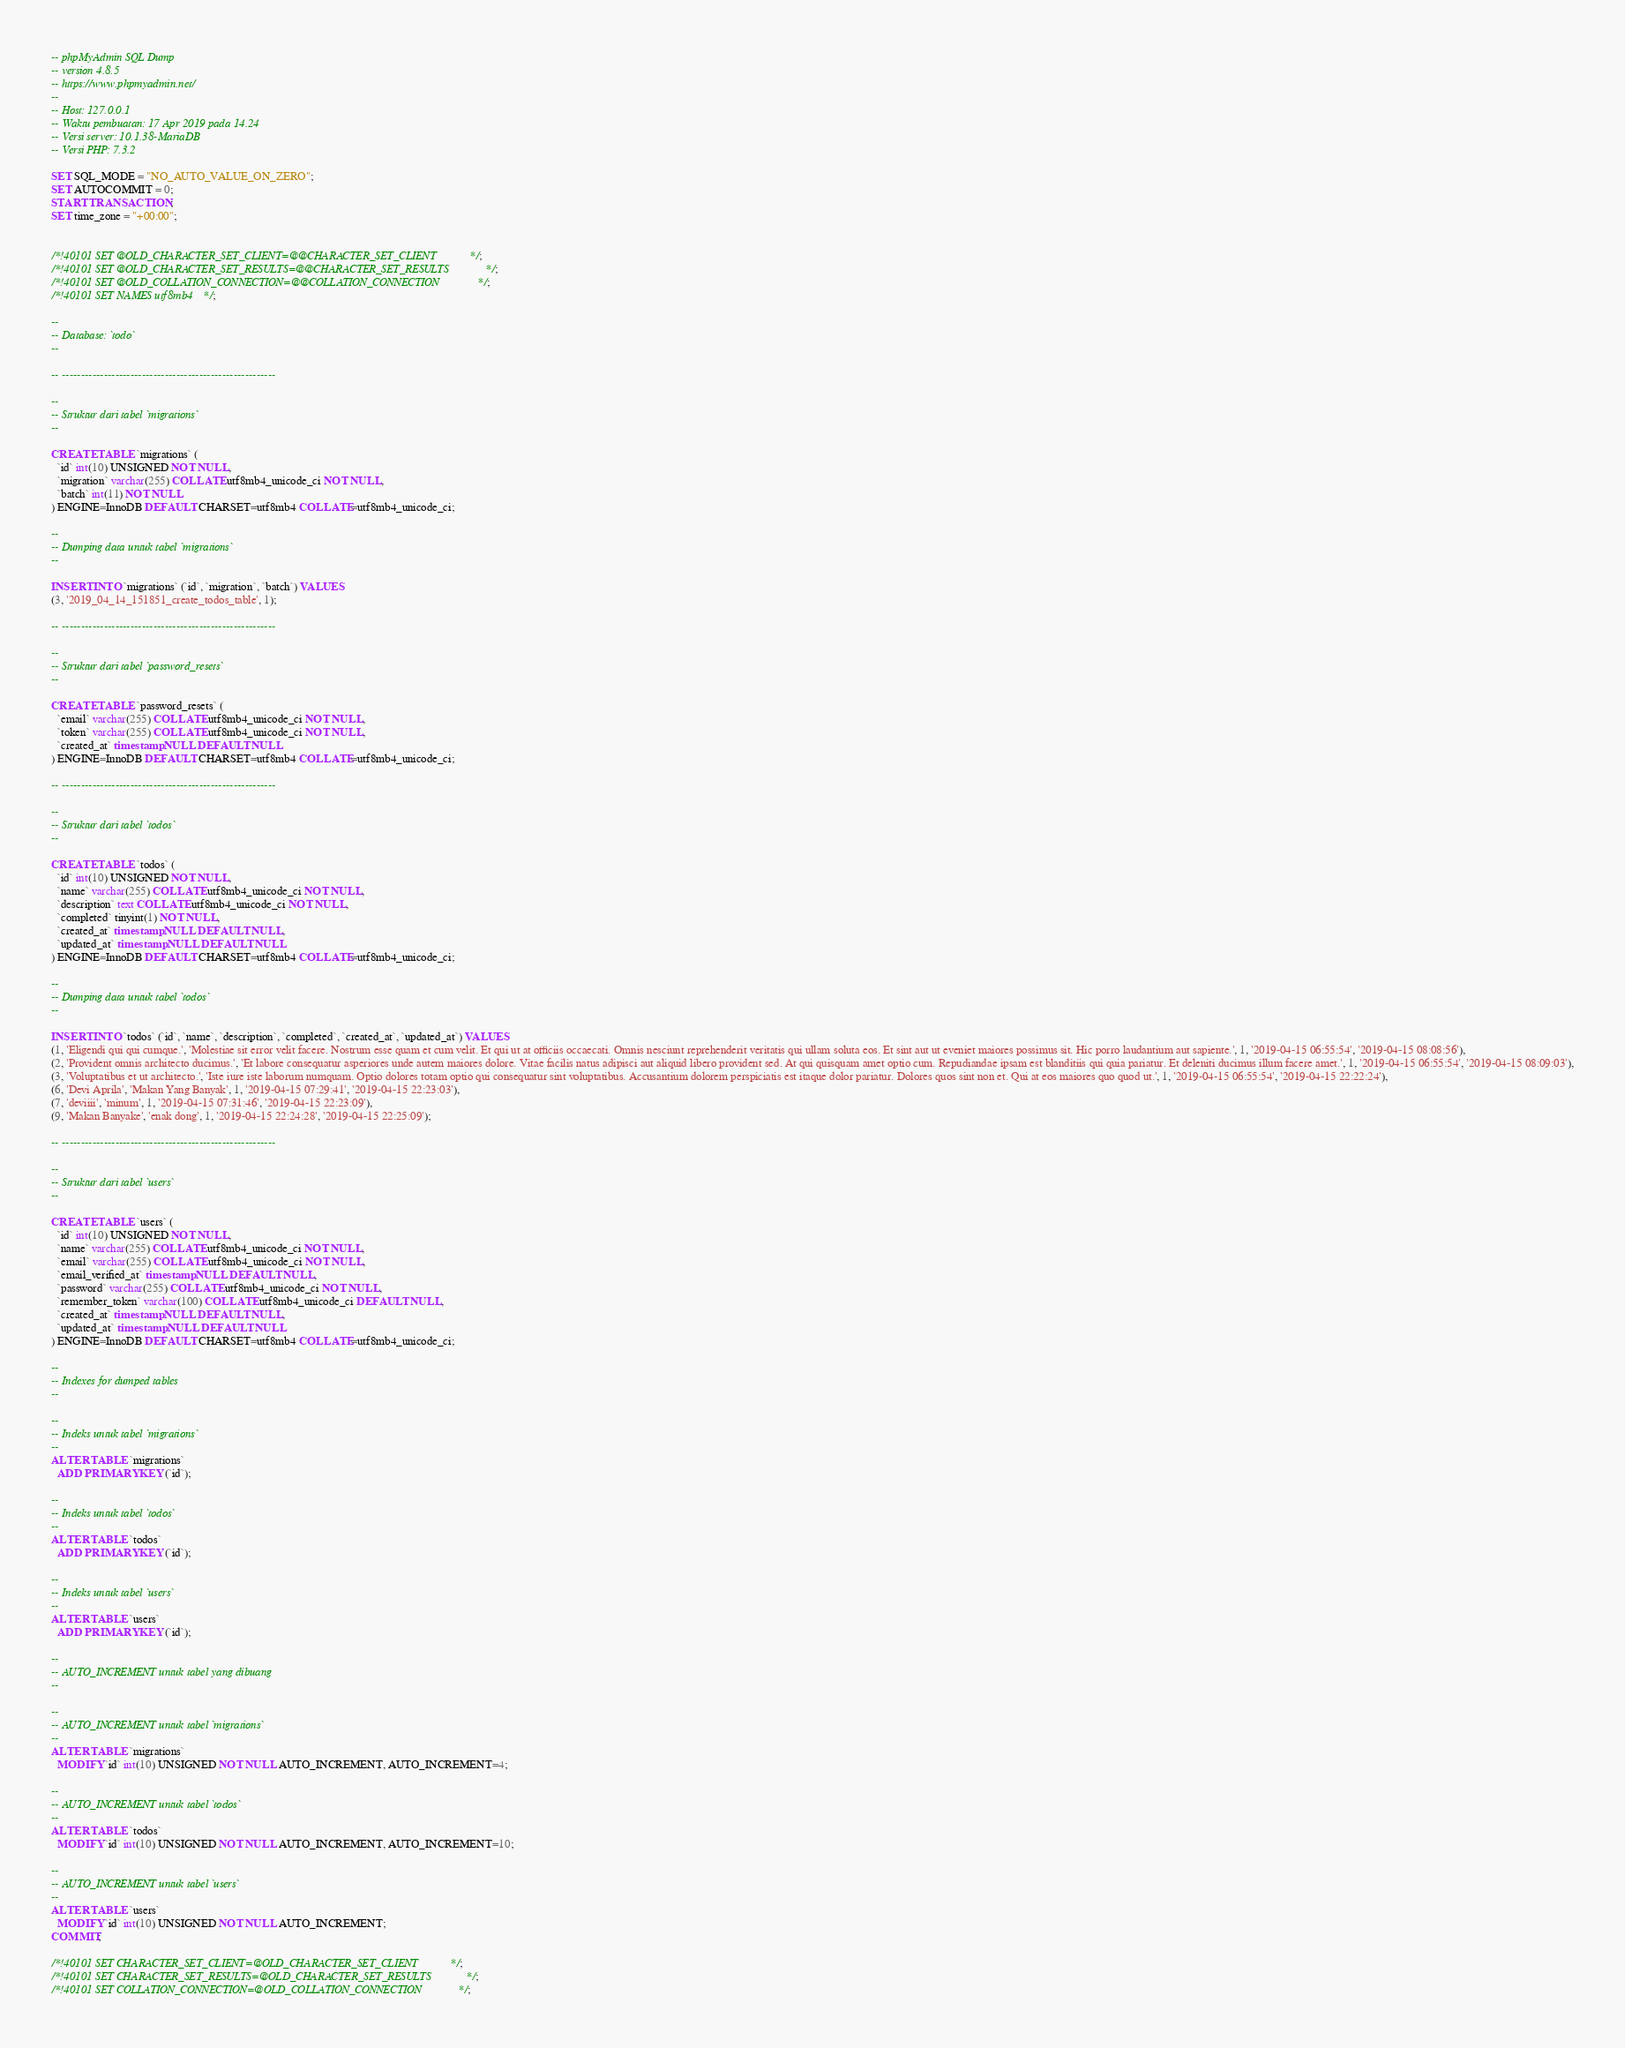<code> <loc_0><loc_0><loc_500><loc_500><_SQL_>-- phpMyAdmin SQL Dump
-- version 4.8.5
-- https://www.phpmyadmin.net/
--
-- Host: 127.0.0.1
-- Waktu pembuatan: 17 Apr 2019 pada 14.24
-- Versi server: 10.1.38-MariaDB
-- Versi PHP: 7.3.2

SET SQL_MODE = "NO_AUTO_VALUE_ON_ZERO";
SET AUTOCOMMIT = 0;
START TRANSACTION;
SET time_zone = "+00:00";


/*!40101 SET @OLD_CHARACTER_SET_CLIENT=@@CHARACTER_SET_CLIENT */;
/*!40101 SET @OLD_CHARACTER_SET_RESULTS=@@CHARACTER_SET_RESULTS */;
/*!40101 SET @OLD_COLLATION_CONNECTION=@@COLLATION_CONNECTION */;
/*!40101 SET NAMES utf8mb4 */;

--
-- Database: `todo`
--

-- --------------------------------------------------------

--
-- Struktur dari tabel `migrations`
--

CREATE TABLE `migrations` (
  `id` int(10) UNSIGNED NOT NULL,
  `migration` varchar(255) COLLATE utf8mb4_unicode_ci NOT NULL,
  `batch` int(11) NOT NULL
) ENGINE=InnoDB DEFAULT CHARSET=utf8mb4 COLLATE=utf8mb4_unicode_ci;

--
-- Dumping data untuk tabel `migrations`
--

INSERT INTO `migrations` (`id`, `migration`, `batch`) VALUES
(3, '2019_04_14_151851_create_todos_table', 1);

-- --------------------------------------------------------

--
-- Struktur dari tabel `password_resets`
--

CREATE TABLE `password_resets` (
  `email` varchar(255) COLLATE utf8mb4_unicode_ci NOT NULL,
  `token` varchar(255) COLLATE utf8mb4_unicode_ci NOT NULL,
  `created_at` timestamp NULL DEFAULT NULL
) ENGINE=InnoDB DEFAULT CHARSET=utf8mb4 COLLATE=utf8mb4_unicode_ci;

-- --------------------------------------------------------

--
-- Struktur dari tabel `todos`
--

CREATE TABLE `todos` (
  `id` int(10) UNSIGNED NOT NULL,
  `name` varchar(255) COLLATE utf8mb4_unicode_ci NOT NULL,
  `description` text COLLATE utf8mb4_unicode_ci NOT NULL,
  `completed` tinyint(1) NOT NULL,
  `created_at` timestamp NULL DEFAULT NULL,
  `updated_at` timestamp NULL DEFAULT NULL
) ENGINE=InnoDB DEFAULT CHARSET=utf8mb4 COLLATE=utf8mb4_unicode_ci;

--
-- Dumping data untuk tabel `todos`
--

INSERT INTO `todos` (`id`, `name`, `description`, `completed`, `created_at`, `updated_at`) VALUES
(1, 'Eligendi qui qui cumque.', 'Molestiae sit error velit facere. Nostrum esse quam et cum velit. Et qui ut at officiis occaecati. Omnis nesciunt reprehenderit veritatis qui ullam soluta eos. Et sint aut ut eveniet maiores possimus sit. Hic porro laudantium aut sapiente.', 1, '2019-04-15 06:55:54', '2019-04-15 08:08:56'),
(2, 'Provident omnis architecto ducimus.', 'Et labore consequatur asperiores unde autem maiores dolore. Vitae facilis natus adipisci aut aliquid libero provident sed. At qui quisquam amet optio cum. Repudiandae ipsam est blanditiis qui quia pariatur. Et deleniti ducimus illum facere amet.', 1, '2019-04-15 06:55:54', '2019-04-15 08:09:03'),
(3, 'Voluptatibus et ut architecto.', 'Iste iure iste laborum numquam. Optio dolores totam optio qui consequatur sint voluptatibus. Accusantium dolorem perspiciatis est itaque dolor pariatur. Dolores quos sint non et. Qui at eos maiores quo quod ut.', 1, '2019-04-15 06:55:54', '2019-04-15 22:22:24'),
(6, 'Devi Aprila', 'Makan Yang Banyak', 1, '2019-04-15 07:29:41', '2019-04-15 22:23:03'),
(7, 'deviiii', 'minum', 1, '2019-04-15 07:31:46', '2019-04-15 22:23:09'),
(9, 'Makan Banyake', 'enak dong', 1, '2019-04-15 22:24:28', '2019-04-15 22:25:09');

-- --------------------------------------------------------

--
-- Struktur dari tabel `users`
--

CREATE TABLE `users` (
  `id` int(10) UNSIGNED NOT NULL,
  `name` varchar(255) COLLATE utf8mb4_unicode_ci NOT NULL,
  `email` varchar(255) COLLATE utf8mb4_unicode_ci NOT NULL,
  `email_verified_at` timestamp NULL DEFAULT NULL,
  `password` varchar(255) COLLATE utf8mb4_unicode_ci NOT NULL,
  `remember_token` varchar(100) COLLATE utf8mb4_unicode_ci DEFAULT NULL,
  `created_at` timestamp NULL DEFAULT NULL,
  `updated_at` timestamp NULL DEFAULT NULL
) ENGINE=InnoDB DEFAULT CHARSET=utf8mb4 COLLATE=utf8mb4_unicode_ci;

--
-- Indexes for dumped tables
--

--
-- Indeks untuk tabel `migrations`
--
ALTER TABLE `migrations`
  ADD PRIMARY KEY (`id`);

--
-- Indeks untuk tabel `todos`
--
ALTER TABLE `todos`
  ADD PRIMARY KEY (`id`);

--
-- Indeks untuk tabel `users`
--
ALTER TABLE `users`
  ADD PRIMARY KEY (`id`);

--
-- AUTO_INCREMENT untuk tabel yang dibuang
--

--
-- AUTO_INCREMENT untuk tabel `migrations`
--
ALTER TABLE `migrations`
  MODIFY `id` int(10) UNSIGNED NOT NULL AUTO_INCREMENT, AUTO_INCREMENT=4;

--
-- AUTO_INCREMENT untuk tabel `todos`
--
ALTER TABLE `todos`
  MODIFY `id` int(10) UNSIGNED NOT NULL AUTO_INCREMENT, AUTO_INCREMENT=10;

--
-- AUTO_INCREMENT untuk tabel `users`
--
ALTER TABLE `users`
  MODIFY `id` int(10) UNSIGNED NOT NULL AUTO_INCREMENT;
COMMIT;

/*!40101 SET CHARACTER_SET_CLIENT=@OLD_CHARACTER_SET_CLIENT */;
/*!40101 SET CHARACTER_SET_RESULTS=@OLD_CHARACTER_SET_RESULTS */;
/*!40101 SET COLLATION_CONNECTION=@OLD_COLLATION_CONNECTION */;
</code> 